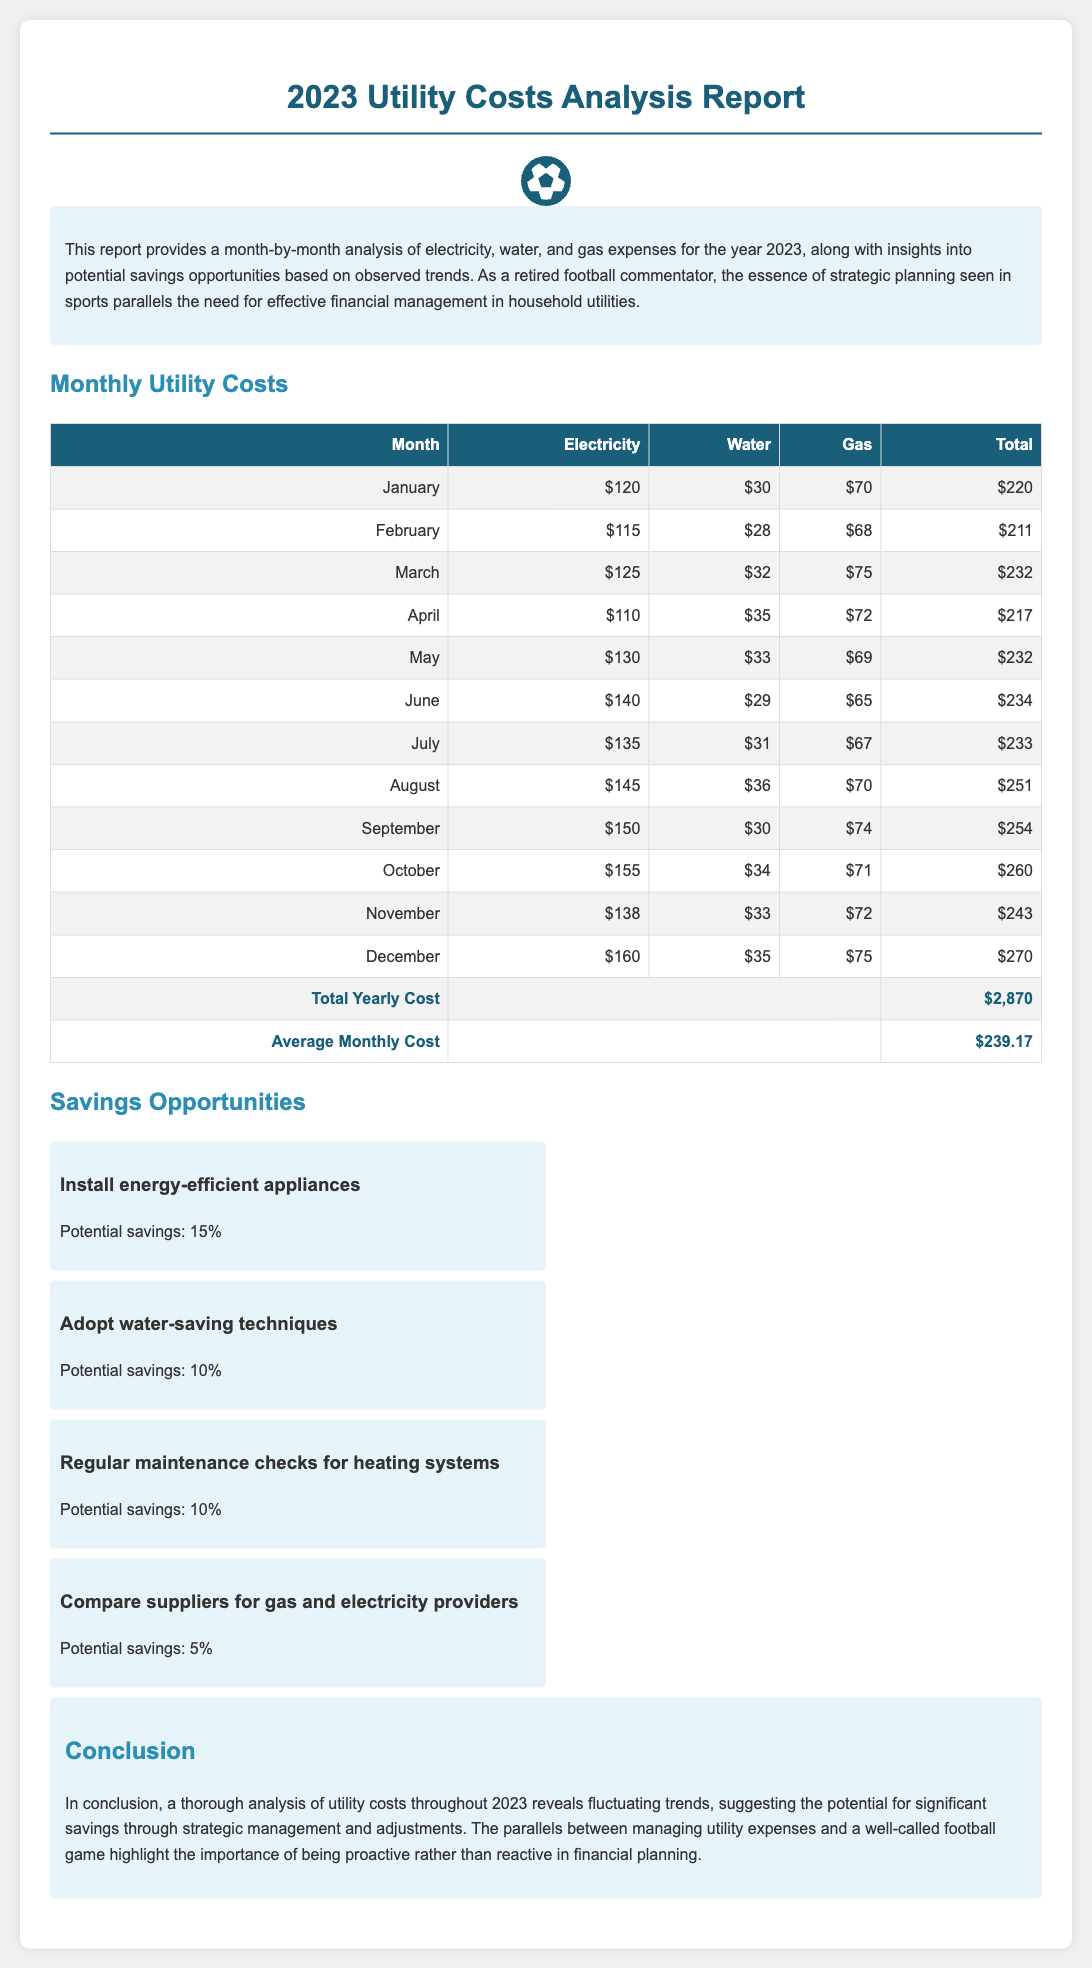What was the total yearly cost of utilities in 2023? The total yearly cost is listed at the bottom of the monthly costs table.
Answer: $2,870 What was the average monthly cost of utilities? The average monthly cost is provided right after the total yearly cost in the document.
Answer: $239.17 Which month had the highest electricity cost? By comparing the monthly electricity values in the table, we identify the month with the highest amount.
Answer: December What potential savings can be realized by installing energy-efficient appliances? The document specifies the potential savings associated with installing energy-efficient appliances.
Answer: 15% In which month was the total utility cost the lowest? By examining the total column in the monthly costs table, we can determine the month with the lowest total cost.
Answer: February What saving technique suggests a potential 10% savings? The document lists several savings opportunities and indicates which ones offer 10% potential savings.
Answer: Adopt water-saving techniques What is the highest gas cost recorded in the report? The highest gas expense is found by looking at the gas values for each month in the document.
Answer: $75 Which month recorded a total cost of $254? The document presents a detailed monthly utility cost overview, making it easy to spot the month with this total.
Answer: September What savings opportunity is suggested for gas and electricity providers? The report indicates a method to save on utilities specifically related to suppliers of gas and electricity.
Answer: Compare suppliers for gas and electricity providers What color highlights the headings of the cost table? The color used for the table headings is noted in the styling of the document.
Answer: White 